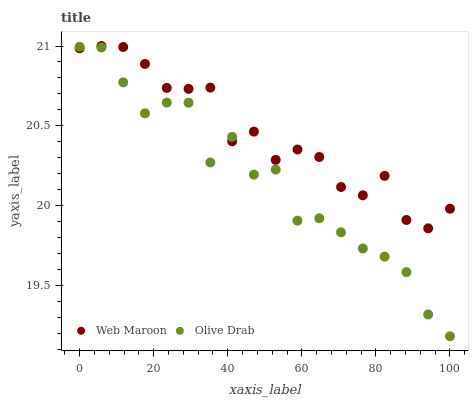Does Olive Drab have the minimum area under the curve?
Answer yes or no. Yes. Does Web Maroon have the maximum area under the curve?
Answer yes or no. Yes. Does Olive Drab have the maximum area under the curve?
Answer yes or no. No. Is Web Maroon the smoothest?
Answer yes or no. Yes. Is Olive Drab the roughest?
Answer yes or no. Yes. Is Olive Drab the smoothest?
Answer yes or no. No. Does Olive Drab have the lowest value?
Answer yes or no. Yes. Does Web Maroon have the highest value?
Answer yes or no. Yes. Does Olive Drab have the highest value?
Answer yes or no. No. Does Web Maroon intersect Olive Drab?
Answer yes or no. Yes. Is Web Maroon less than Olive Drab?
Answer yes or no. No. Is Web Maroon greater than Olive Drab?
Answer yes or no. No. 